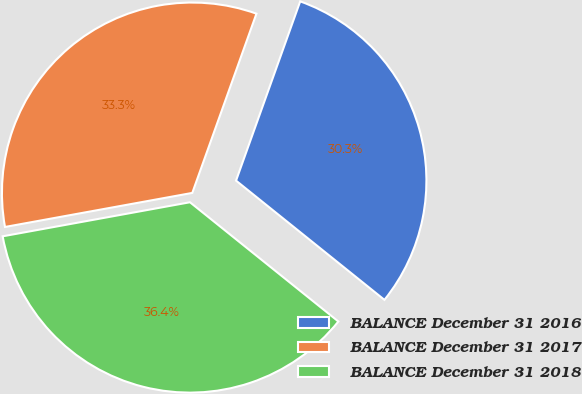Convert chart. <chart><loc_0><loc_0><loc_500><loc_500><pie_chart><fcel>BALANCE December 31 2016<fcel>BALANCE December 31 2017<fcel>BALANCE December 31 2018<nl><fcel>30.3%<fcel>33.33%<fcel>36.36%<nl></chart> 